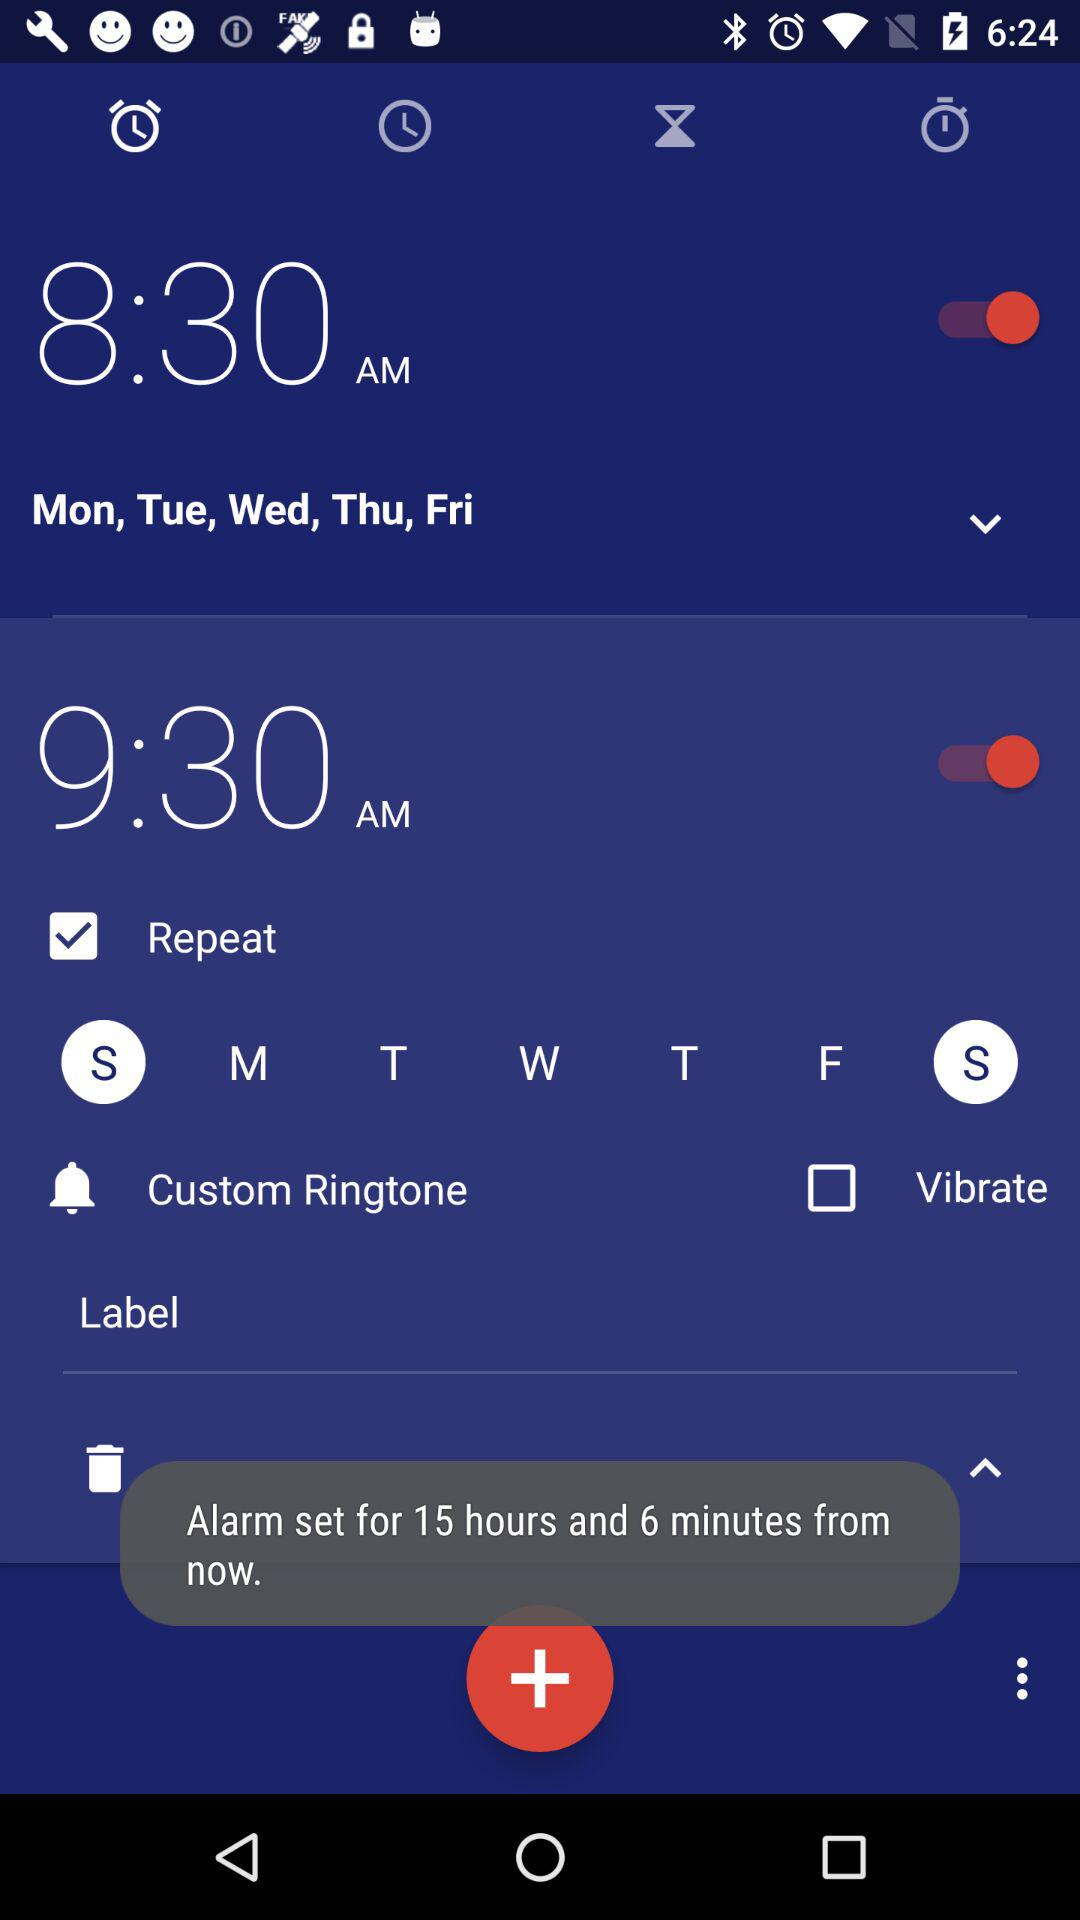For how much time has the alarm been set? The alarm has been set for 15 hours and 6 minutes from now. 